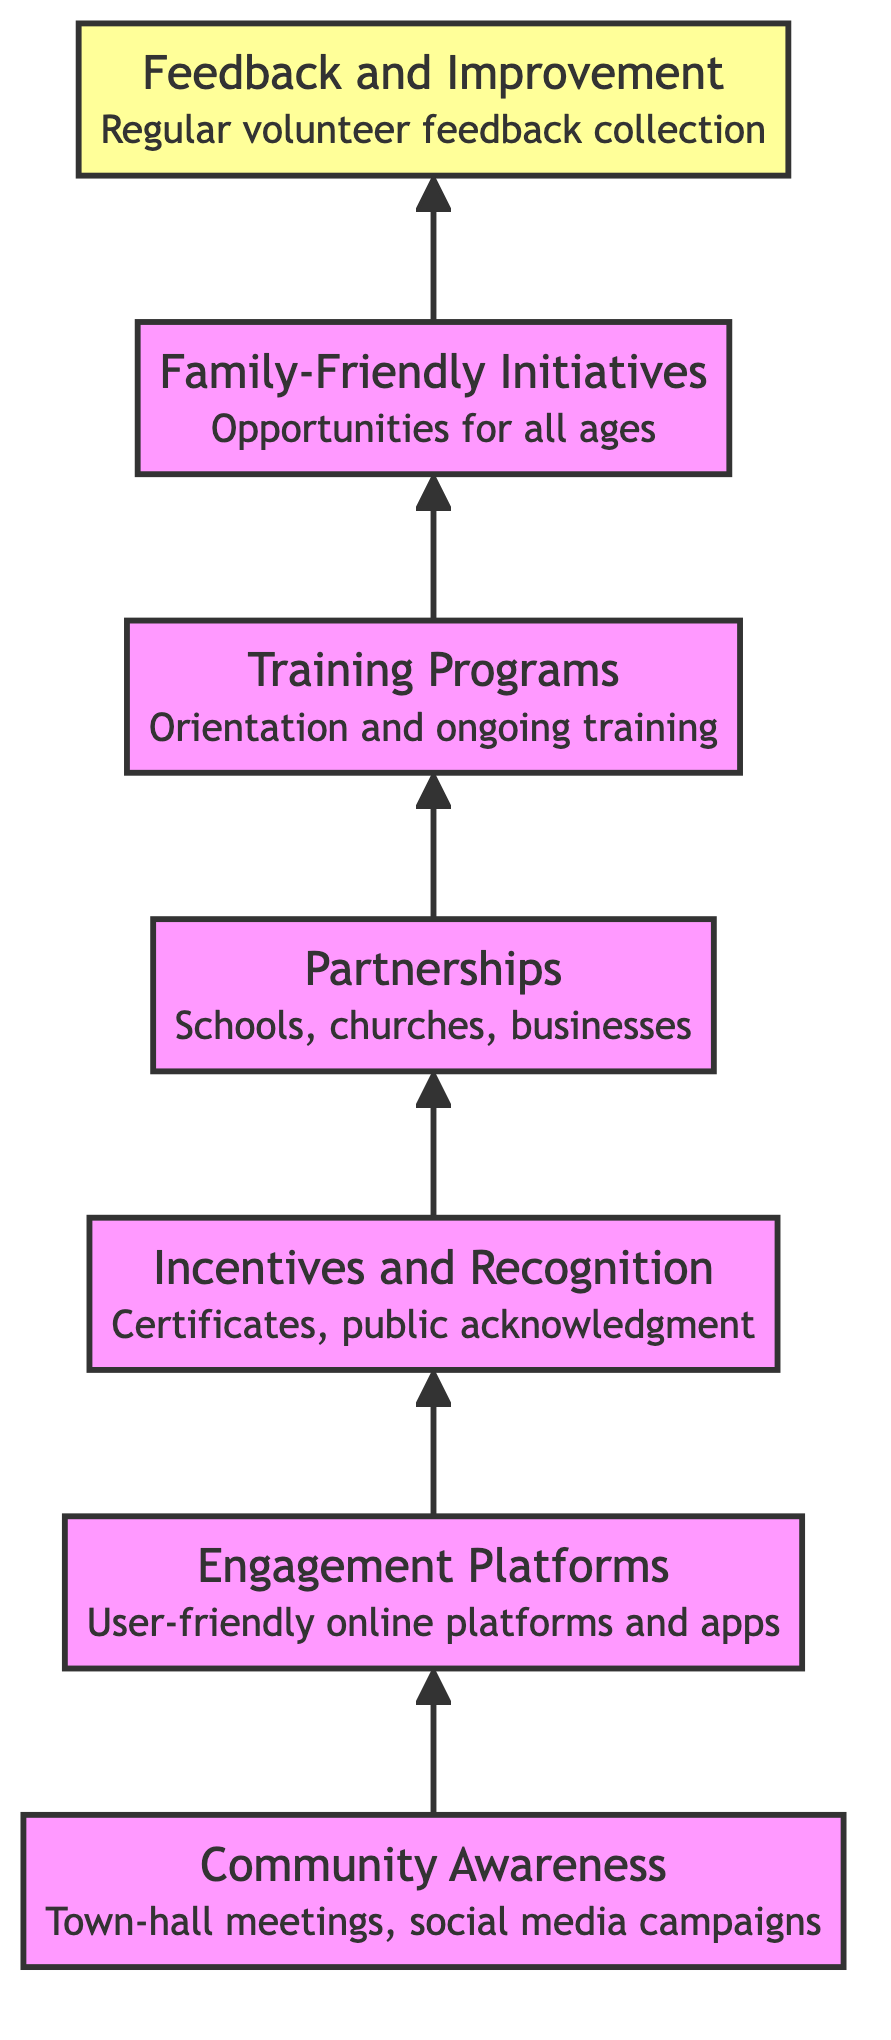What is the top node in the diagram? The top node represents the final outcome or goal of the flow chart. In this case, it is "Feedback and Improvement," which is specifically indicated to be at the top position according to the flow direction.
Answer: Feedback and Improvement How many nodes are there in total? By counting the distinct elements listed in the diagram, we find there are seven unique nodes representing different stages or components of volunteer recruitment and retention.
Answer: 7 What connects "Community Awareness" to "Engagement Platforms"? The relationship between "Community Awareness" and "Engagement Platforms" is one of progression, where awareness efforts lead to the establishment of platforms for engagement. This direct connection is displayed with an arrow pointing from the first to the second node.
Answer: Engagement Platforms Which node involves forming partnerships? The node that involves forming partnerships is clearly labeled "Partnerships with Local Organizations," and it denotes collaborative efforts with various local entities to enhance volunteer engagement.
Answer: Partnerships with Local Organizations What is the purpose of the "Incentives and Recognition" node? The "Incentives and Recognition" node is designed to retain volunteers by providing them with rewards and acknowledgment. This is crucial for maintaining motivation and encouraging ongoing participation among volunteers.
Answer: Retain volunteers Explain the flow from "Volunteer Training Programs" to "Family-Friendly Initiatives." What does it indicate? The flow between these two nodes suggests that once volunteers are trained and equipped with necessary skills through the "Volunteer Training Programs," efforts can then be made to develop "Family-Friendly Initiatives," which aim to engage whole families in volunteer activities. This indicates a sequential development where training supports broader community involvement.
Answer: Sequential development What is the key focus of the "Feedback and Improvement" node? The key focus of the "Feedback and Improvement" node is on regularly collecting feedback from volunteers, which is essential for making continuous improvements to retention strategies and maintaining volunteer motivation over time.
Answer: Regular feedback collection How does "Engagement Platforms" relate to "Incentives and Recognition"? The "Engagement Platforms" serve as a means to communicate and provide updates on local initiatives, which can facilitate the implementation of "Incentives and Recognition" by keeping volunteers informed about their rewards and acknowledgments. This connection underlines that effective engagement can lead to better retention through recognition.
Answer: Facilitate retention 